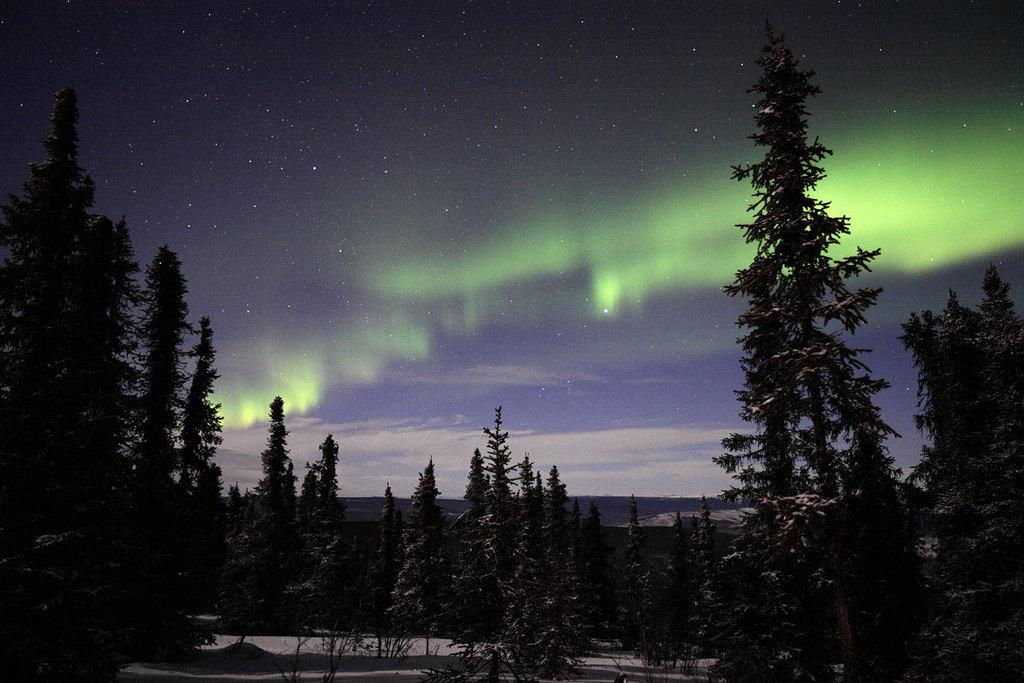What type of vegetation can be seen in the image? There are trees in the image. What is covering the ground in the image? It appears to be snow in the image. What part of the natural environment is visible in the image? The sky is visible in the image. What type of appliance can be seen in the image? There is no appliance present in the image. What type of industry is depicted in the image? There is no industry depicted in the image. 